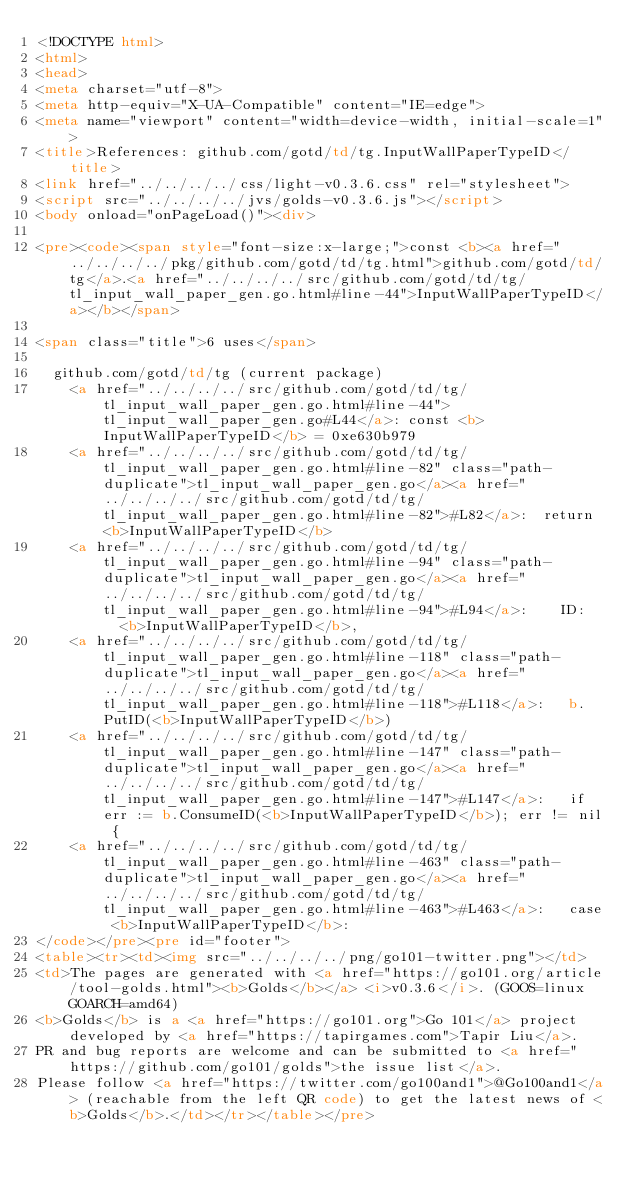Convert code to text. <code><loc_0><loc_0><loc_500><loc_500><_HTML_><!DOCTYPE html>
<html>
<head>
<meta charset="utf-8">
<meta http-equiv="X-UA-Compatible" content="IE=edge">
<meta name="viewport" content="width=device-width, initial-scale=1">
<title>References: github.com/gotd/td/tg.InputWallPaperTypeID</title>
<link href="../../../../css/light-v0.3.6.css" rel="stylesheet">
<script src="../../../../jvs/golds-v0.3.6.js"></script>
<body onload="onPageLoad()"><div>

<pre><code><span style="font-size:x-large;">const <b><a href="../../../../pkg/github.com/gotd/td/tg.html">github.com/gotd/td/tg</a>.<a href="../../../../src/github.com/gotd/td/tg/tl_input_wall_paper_gen.go.html#line-44">InputWallPaperTypeID</a></b></span>

<span class="title">6 uses</span>

	github.com/gotd/td/tg (current package)
		<a href="../../../../src/github.com/gotd/td/tg/tl_input_wall_paper_gen.go.html#line-44">tl_input_wall_paper_gen.go#L44</a>: const <b>InputWallPaperTypeID</b> = 0xe630b979
		<a href="../../../../src/github.com/gotd/td/tg/tl_input_wall_paper_gen.go.html#line-82" class="path-duplicate">tl_input_wall_paper_gen.go</a><a href="../../../../src/github.com/gotd/td/tg/tl_input_wall_paper_gen.go.html#line-82">#L82</a>: 	return <b>InputWallPaperTypeID</b>
		<a href="../../../../src/github.com/gotd/td/tg/tl_input_wall_paper_gen.go.html#line-94" class="path-duplicate">tl_input_wall_paper_gen.go</a><a href="../../../../src/github.com/gotd/td/tg/tl_input_wall_paper_gen.go.html#line-94">#L94</a>: 		ID:   <b>InputWallPaperTypeID</b>,
		<a href="../../../../src/github.com/gotd/td/tg/tl_input_wall_paper_gen.go.html#line-118" class="path-duplicate">tl_input_wall_paper_gen.go</a><a href="../../../../src/github.com/gotd/td/tg/tl_input_wall_paper_gen.go.html#line-118">#L118</a>: 	b.PutID(<b>InputWallPaperTypeID</b>)
		<a href="../../../../src/github.com/gotd/td/tg/tl_input_wall_paper_gen.go.html#line-147" class="path-duplicate">tl_input_wall_paper_gen.go</a><a href="../../../../src/github.com/gotd/td/tg/tl_input_wall_paper_gen.go.html#line-147">#L147</a>: 	if err := b.ConsumeID(<b>InputWallPaperTypeID</b>); err != nil {
		<a href="../../../../src/github.com/gotd/td/tg/tl_input_wall_paper_gen.go.html#line-463" class="path-duplicate">tl_input_wall_paper_gen.go</a><a href="../../../../src/github.com/gotd/td/tg/tl_input_wall_paper_gen.go.html#line-463">#L463</a>: 	case <b>InputWallPaperTypeID</b>:
</code></pre><pre id="footer">
<table><tr><td><img src="../../../../png/go101-twitter.png"></td>
<td>The pages are generated with <a href="https://go101.org/article/tool-golds.html"><b>Golds</b></a> <i>v0.3.6</i>. (GOOS=linux GOARCH=amd64)
<b>Golds</b> is a <a href="https://go101.org">Go 101</a> project developed by <a href="https://tapirgames.com">Tapir Liu</a>.
PR and bug reports are welcome and can be submitted to <a href="https://github.com/go101/golds">the issue list</a>.
Please follow <a href="https://twitter.com/go100and1">@Go100and1</a> (reachable from the left QR code) to get the latest news of <b>Golds</b>.</td></tr></table></pre></code> 